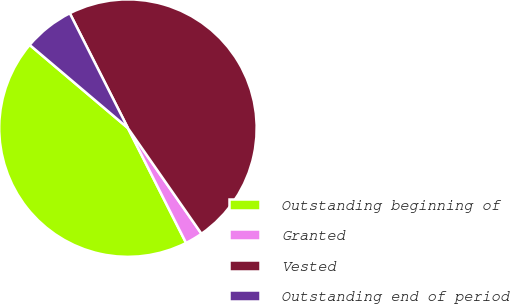Convert chart. <chart><loc_0><loc_0><loc_500><loc_500><pie_chart><fcel>Outstanding beginning of<fcel>Granted<fcel>Vested<fcel>Outstanding end of period<nl><fcel>43.64%<fcel>2.22%<fcel>47.78%<fcel>6.36%<nl></chart> 